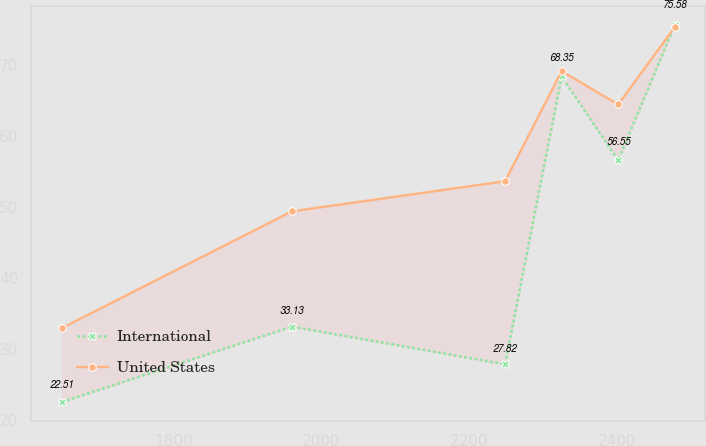<chart> <loc_0><loc_0><loc_500><loc_500><line_chart><ecel><fcel>International<fcel>United States<nl><fcel>1649.05<fcel>22.51<fcel>32.93<nl><fcel>1960.18<fcel>33.13<fcel>49.36<nl><fcel>2248.73<fcel>27.82<fcel>53.6<nl><fcel>2325.24<fcel>68.35<fcel>69.1<nl><fcel>2401.75<fcel>56.55<fcel>64.41<nl><fcel>2478.26<fcel>75.58<fcel>75.29<nl></chart> 